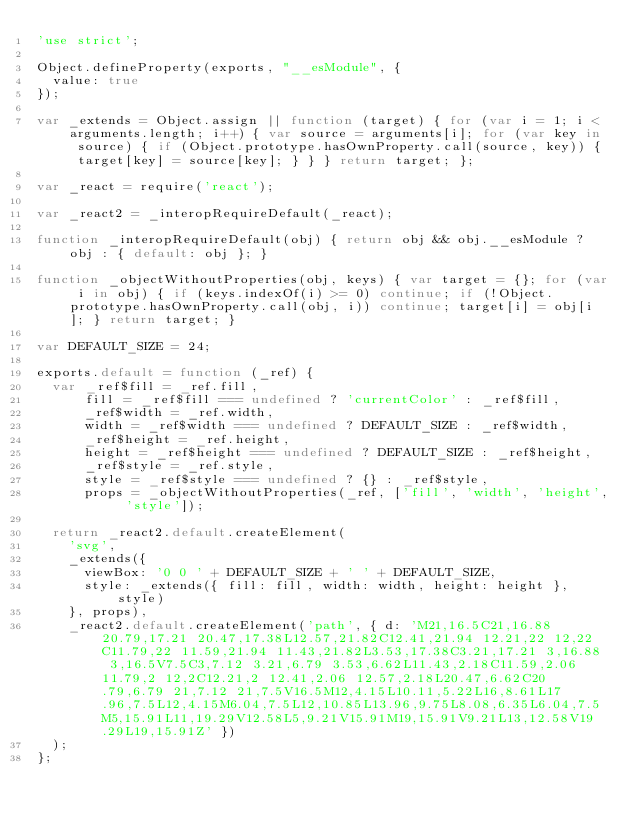<code> <loc_0><loc_0><loc_500><loc_500><_JavaScript_>'use strict';

Object.defineProperty(exports, "__esModule", {
  value: true
});

var _extends = Object.assign || function (target) { for (var i = 1; i < arguments.length; i++) { var source = arguments[i]; for (var key in source) { if (Object.prototype.hasOwnProperty.call(source, key)) { target[key] = source[key]; } } } return target; };

var _react = require('react');

var _react2 = _interopRequireDefault(_react);

function _interopRequireDefault(obj) { return obj && obj.__esModule ? obj : { default: obj }; }

function _objectWithoutProperties(obj, keys) { var target = {}; for (var i in obj) { if (keys.indexOf(i) >= 0) continue; if (!Object.prototype.hasOwnProperty.call(obj, i)) continue; target[i] = obj[i]; } return target; }

var DEFAULT_SIZE = 24;

exports.default = function (_ref) {
  var _ref$fill = _ref.fill,
      fill = _ref$fill === undefined ? 'currentColor' : _ref$fill,
      _ref$width = _ref.width,
      width = _ref$width === undefined ? DEFAULT_SIZE : _ref$width,
      _ref$height = _ref.height,
      height = _ref$height === undefined ? DEFAULT_SIZE : _ref$height,
      _ref$style = _ref.style,
      style = _ref$style === undefined ? {} : _ref$style,
      props = _objectWithoutProperties(_ref, ['fill', 'width', 'height', 'style']);

  return _react2.default.createElement(
    'svg',
    _extends({
      viewBox: '0 0 ' + DEFAULT_SIZE + ' ' + DEFAULT_SIZE,
      style: _extends({ fill: fill, width: width, height: height }, style)
    }, props),
    _react2.default.createElement('path', { d: 'M21,16.5C21,16.88 20.79,17.21 20.47,17.38L12.57,21.82C12.41,21.94 12.21,22 12,22C11.79,22 11.59,21.94 11.43,21.82L3.53,17.38C3.21,17.21 3,16.88 3,16.5V7.5C3,7.12 3.21,6.79 3.53,6.62L11.43,2.18C11.59,2.06 11.79,2 12,2C12.21,2 12.41,2.06 12.57,2.18L20.47,6.62C20.79,6.79 21,7.12 21,7.5V16.5M12,4.15L10.11,5.22L16,8.61L17.96,7.5L12,4.15M6.04,7.5L12,10.85L13.96,9.75L8.08,6.35L6.04,7.5M5,15.91L11,19.29V12.58L5,9.21V15.91M19,15.91V9.21L13,12.58V19.29L19,15.91Z' })
  );
};</code> 